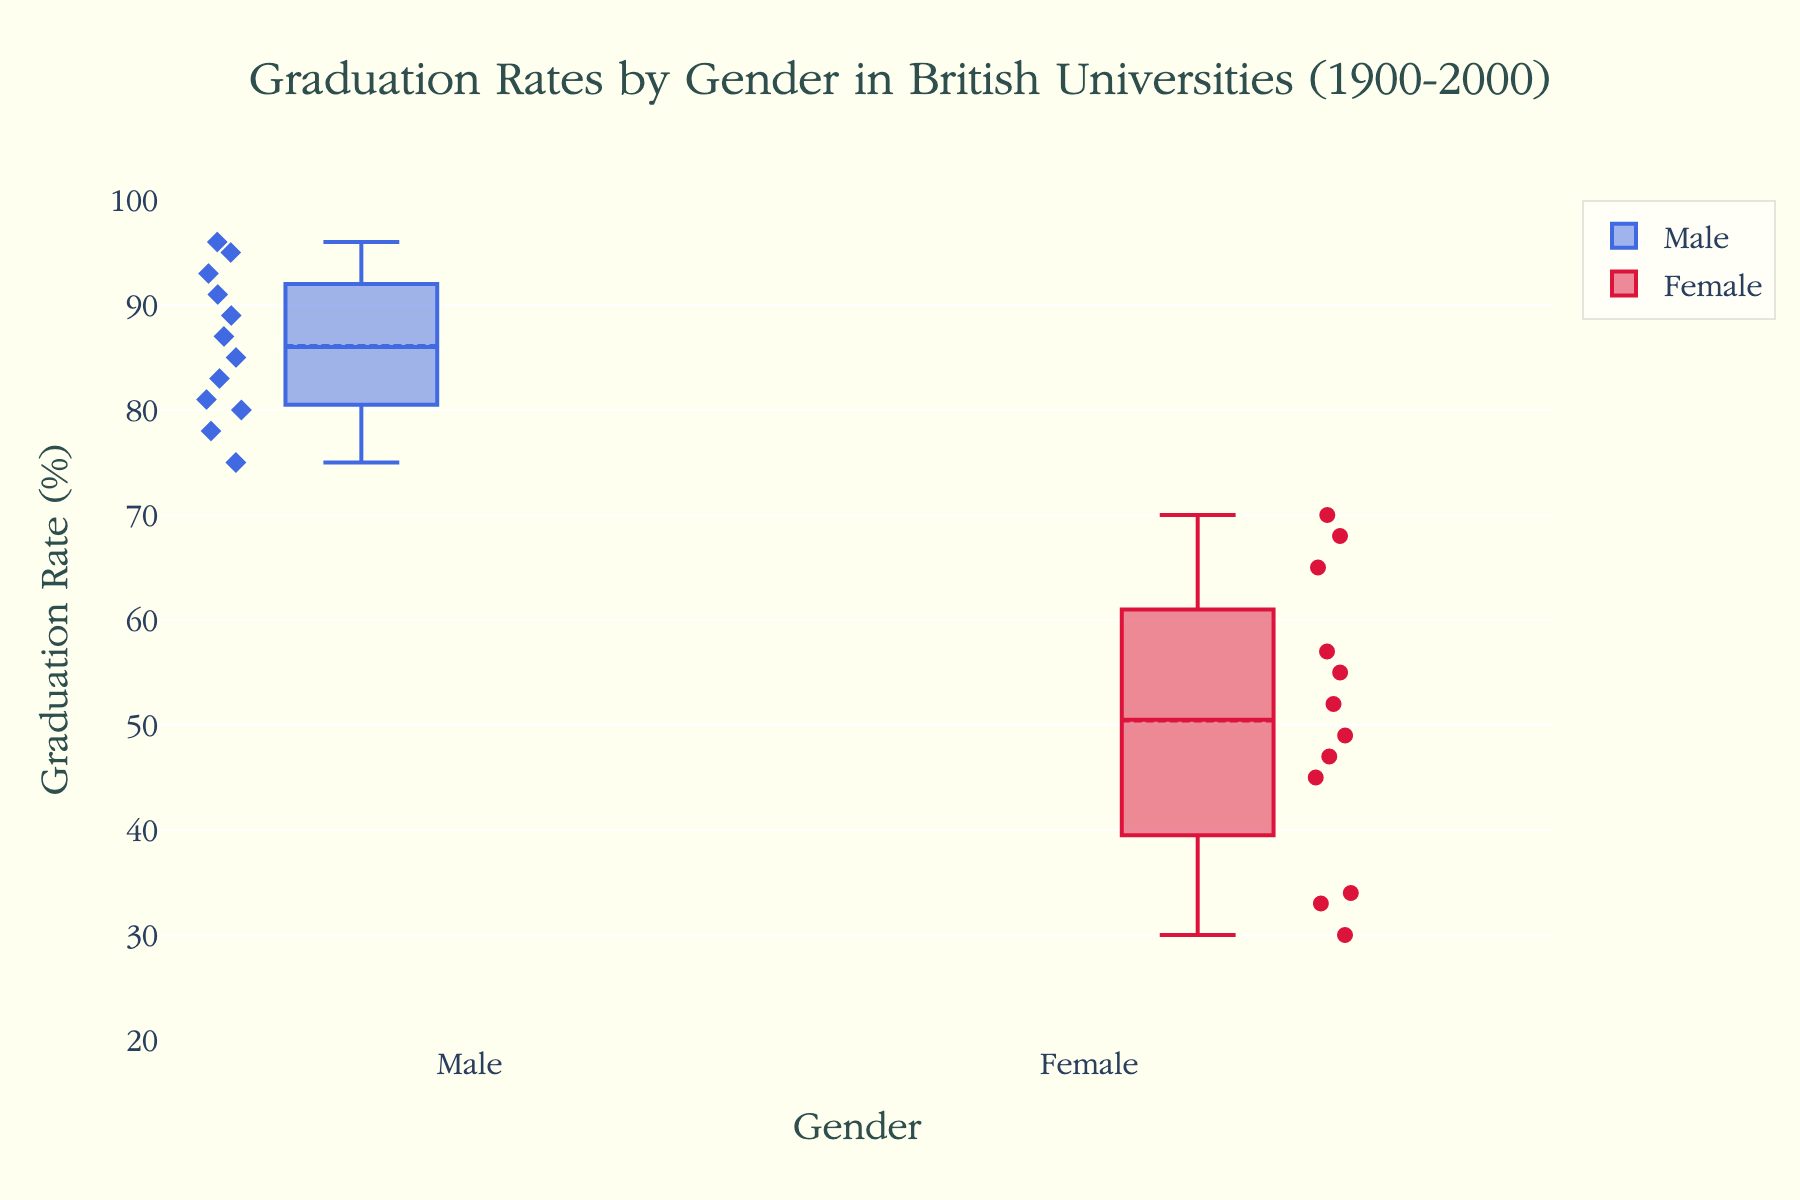What is the title of the figure? The title is usually located at the top of the figure, and in this case, it should be fairly readable. The title is "Graduation Rates by Gender in British Universities (1900-2000)."
Answer: "Graduation Rates by Gender in British Universities (1900-2000)" What is the range of the y-axis in the figure? The y-axis shows the graduation rates, and the range can usually be determined by looking at the lowest and highest numbers on the y-axis. In this case, it ranges from 20 to 100.
Answer: 20 to 100 Which gender has a higher median graduation rate? Box plots display the median as a line inside the box. By comparing the medians of both boxes, we see that the female box plot has a higher line, indicating a higher median.
Answer: Female What are the colors used for the male and female data points, respectively? The colors of the male and female data points can be identified by looking at the legend or the visual elements of the plots. The male data points are colored in royal blue, and the female data points are colored in crimson.
Answer: Royal blue and crimson What is the interquartile range (IQR) for male graduation rates? The IQR can be calculated by subtracting the lower quartile (Q1) from the upper quartile (Q3). The Q1 and Q3 values can be read off the box plot for the male group. Suppose Q1 is around 80 and Q3 is around 91. Then, the IQR is 91 - 80 = 11.
Answer: 11 How do the graduation rates for females compare between 1900 and 2000? Look at the individual points representing the female graduation rates for 1900 and 2000. In 1900, rates are notably lower, while in 2000, they are much higher, improving significantly from around 30 to 70.
Answer: Improved significantly Are there outliers in the male graduation rate data? Outliers in a box plot are often displayed as individual points outside the whiskers. Here, there are no obvious outlier points marked for the male graduation rate.
Answer: No By approximately how many percentage points do male graduation rates decrease from 1900 to 2000? Identify the male graduation rates for 1900 and 2000 from the respective points. The rate in 1900 is around 95, and in 2000, it is 75. The decrease is 95 - 75 = 20 percentage points.
Answer: 20 percentage points How does the variation in female graduation rates compare to male graduation rates over the century? Examine the length of the boxes and the spread of the points. Female graduation rates have a wider spread and greater interquartile range, indicating more variation compared to male rates, which are more tightly clustered.
Answer: Female rates have greater variation 